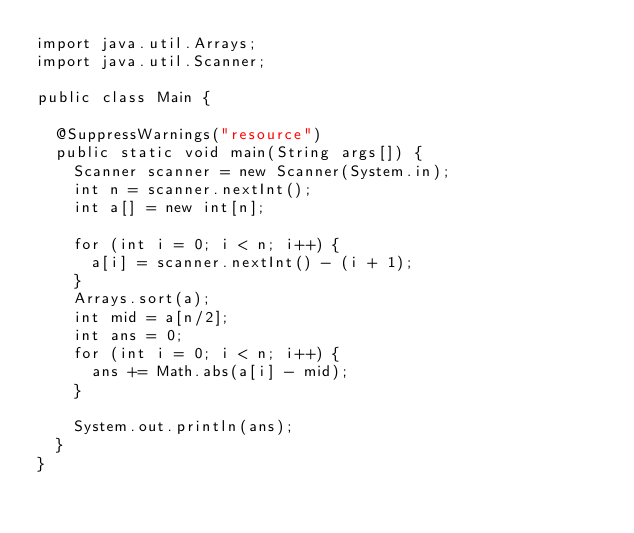<code> <loc_0><loc_0><loc_500><loc_500><_Java_>import java.util.Arrays;
import java.util.Scanner;

public class Main {

	@SuppressWarnings("resource")
	public static void main(String args[]) {
		Scanner scanner = new Scanner(System.in);
		int n = scanner.nextInt();
		int a[] = new int[n];

		for (int i = 0; i < n; i++) {
			a[i] = scanner.nextInt() - (i + 1);
		}
		Arrays.sort(a);
		int mid = a[n/2];
		int ans = 0;
		for (int i = 0; i < n; i++) {
			ans += Math.abs(a[i] - mid);
		}

		System.out.println(ans);
	}
}
</code> 